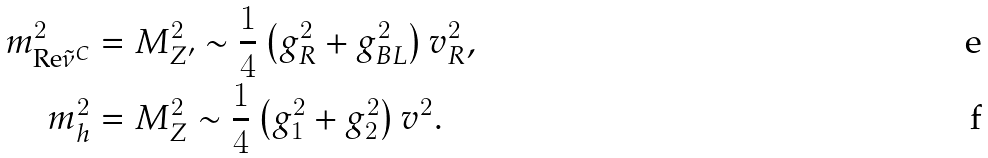<formula> <loc_0><loc_0><loc_500><loc_500>m ^ { 2 } _ { \text {Re} \tilde { \nu } ^ { C } } & = M _ { Z ^ { \prime } } ^ { 2 } \sim \frac { 1 } { 4 } \left ( g _ { R } ^ { 2 } + g _ { B L } ^ { 2 } \right ) v _ { R } ^ { 2 } , \\ m ^ { 2 } _ { h } & = M _ { Z } ^ { 2 } \sim \frac { 1 } { 4 } \left ( g _ { 1 } ^ { 2 } + g _ { 2 } ^ { 2 } \right ) v ^ { 2 } .</formula> 